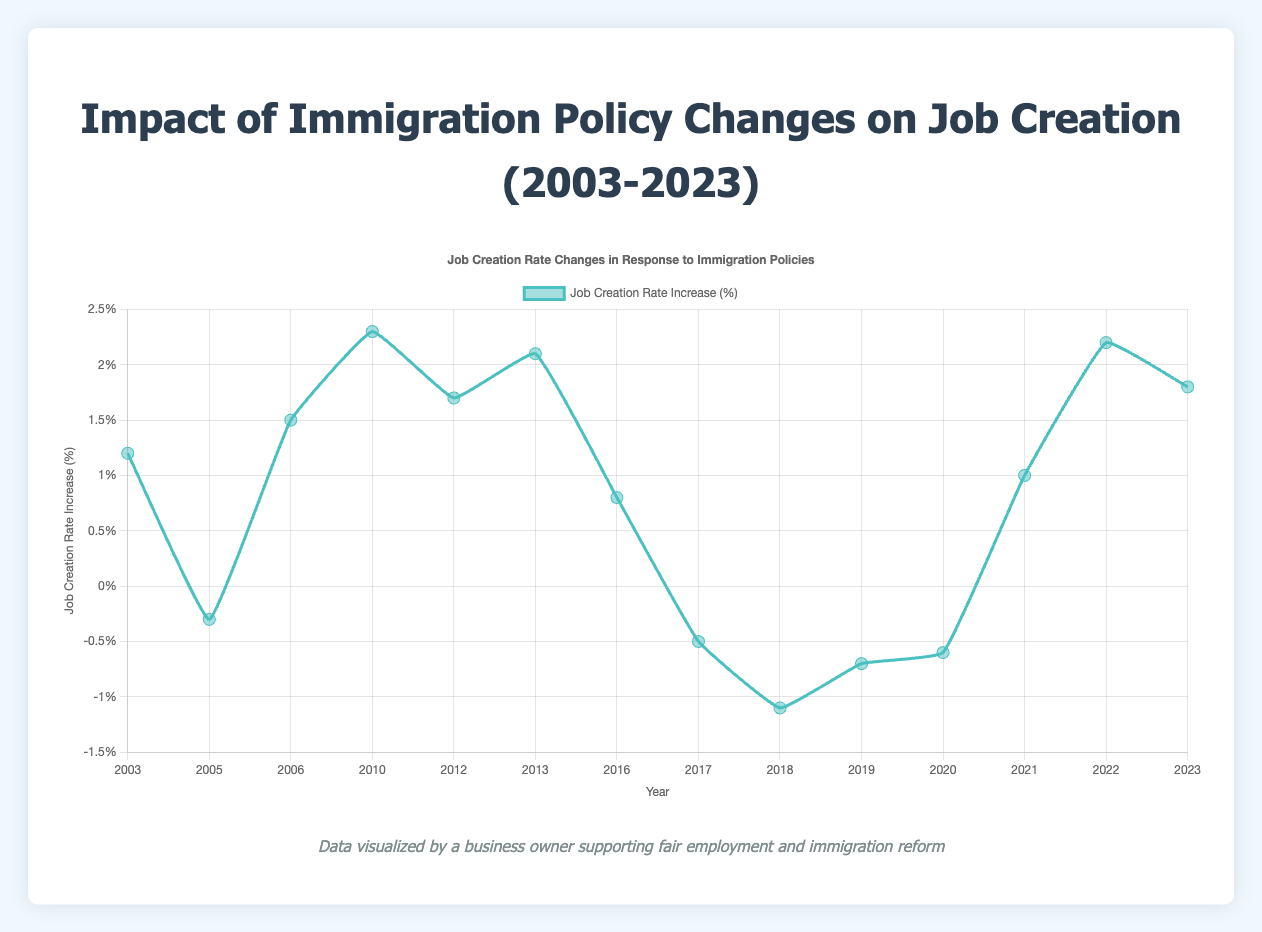Which year saw the highest increase in job creation rate and by how much? Looking at the peaks in the line plot, the highest increase in job creation rate occurred in 2010 with a rate increase of 2.3%.
Answer: 2010, 2.3% What was the job creation rate increase in 2019 compared to 2006? In 2006, the job creation rate increase was 1.5%, whereas in 2019, it was -0.7%. The difference is 1.5% - (-0.7%) = 2.2%.
Answer: 2.2% Which policy led to the lowest job creation rate increase and what was the rate? Observing the lowest points in the plot, the Family Separations Policy in 2018 resulted in the lowest job creation rate increase of -1.1%.
Answer: Family Separations Policy, -1.1% What is the average job creation rate increase for policies introduced between 2010 and 2015 inclusive? The years in this range with recorded values are 2010 (2.3%), 2012 (1.7%), and 2013 (2.1%). The average rate is (2.3% + 1.7% + 2.1%) / 3 = 2.03%.
Answer: 2.03% How many policies resulted in a negative job creation rate increase? Policies with negative job creation rate increases are the Real ID Act (2005: -0.3%), Travel Ban (2017: -0.5%), Family Separations Policy (2018: -1.1%), Public Charge Rule Expansion (2019: -0.7%), and Expanded Travel Ban (2020: -0.6%). Thus, there are 5 policies.
Answer: 5 Compare the job creation rate increase before and after the H-1B Visa Program Changes in 2016. The H-1B Visa Program Changes in 2016 had a rate of 0.8%. Before this, the rate in 2013 was 2.1%. The decrease is 2.1% - 0.8% = 1.3%. After this, in 2017, the rate was -0.5%, a further decrease of 0.8% - (-0.5%) = 1.3%.
Answer: Before: -1.3%, After: -1.3% Which policy change showed the most improvement in job creation rate compared to its preceding policy? The most significant improvement was between the Real ID Act in 2005 (-0.3%) and the Comprehensive Immigration Reform Act in 2006 (1.5%), an increase of 1.5% - (-0.3%) = 1.8%.
Answer: Comprehensive Immigration Reform Act, 1.8% Does any policy have the same job creation rate increase as another? Comparing the values, no two policies share the identical job creation rate increase.
Answer: No 